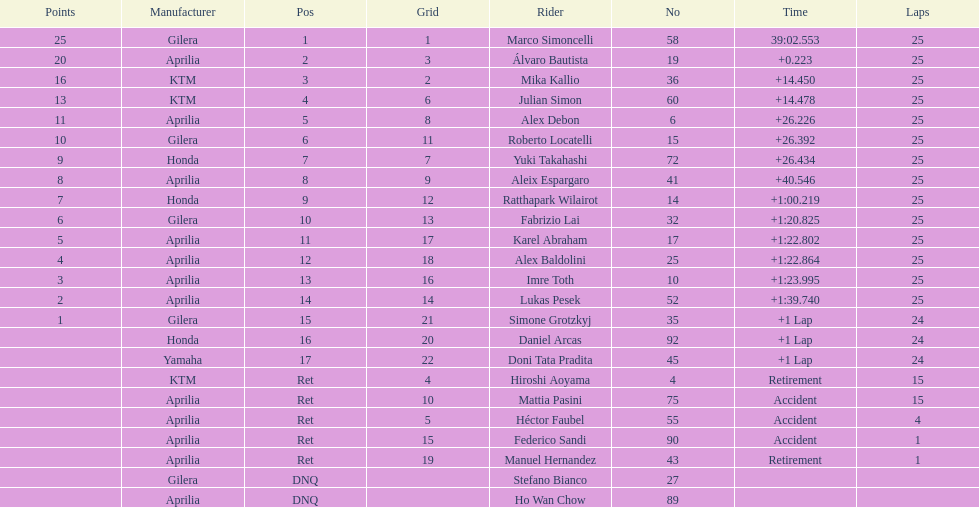What is the total number of laps performed by rider imre toth? 25. 